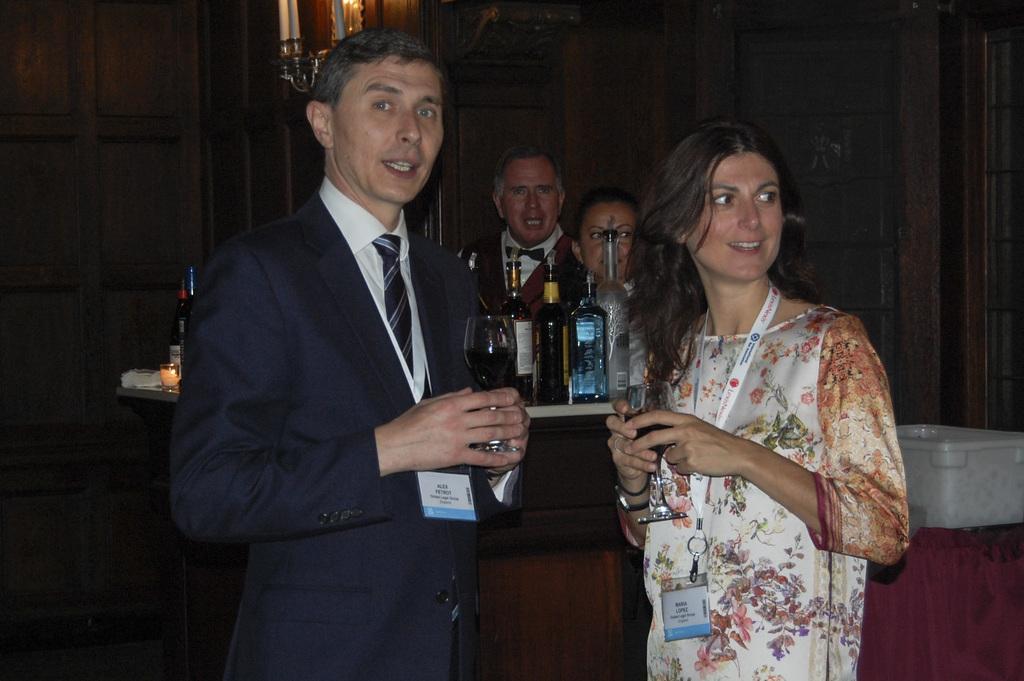How would you summarize this image in a sentence or two? These two people are holding glasses and wore ID cards. On these tables there are bottles. Backside of this table there are people. These are candles. 